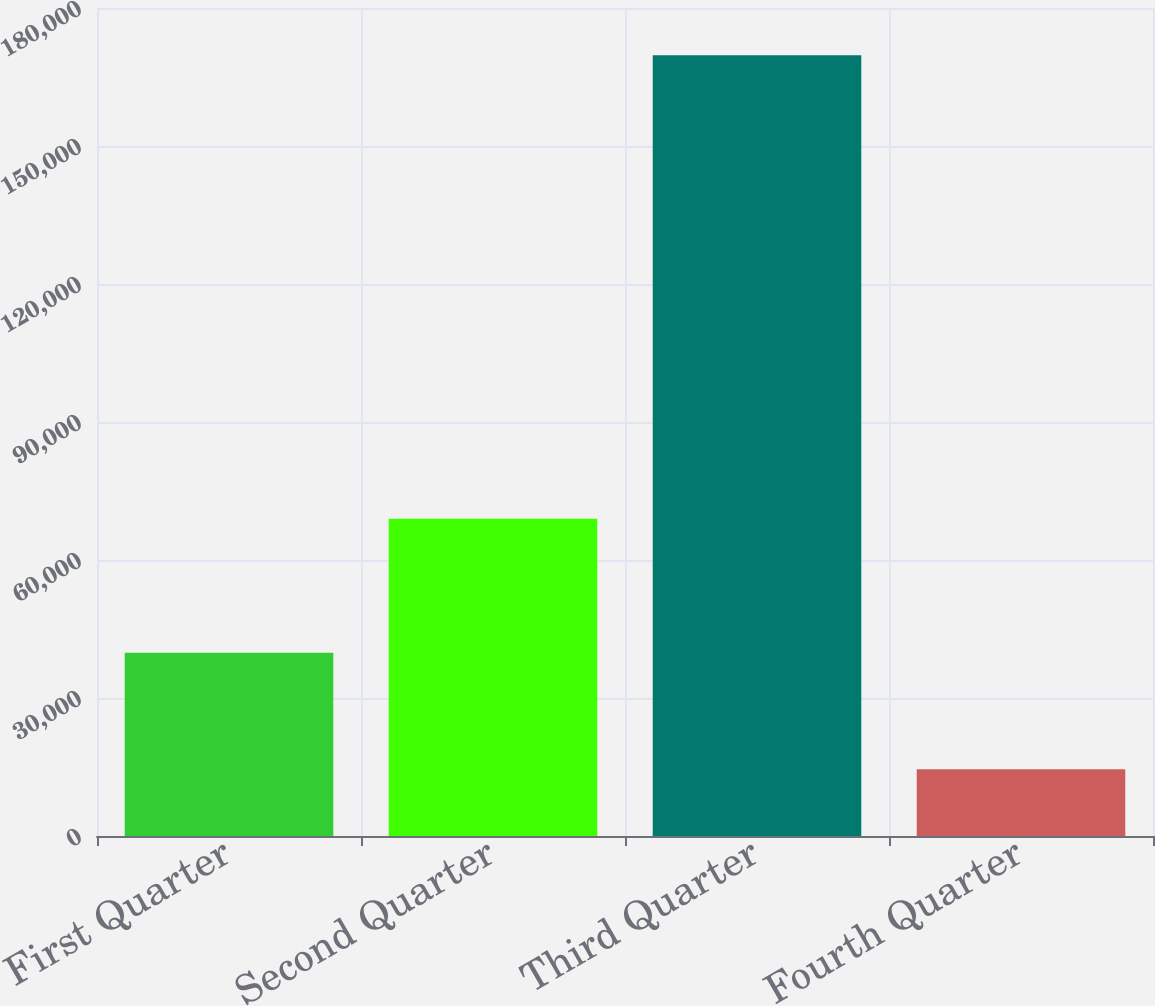Convert chart to OTSL. <chart><loc_0><loc_0><loc_500><loc_500><bar_chart><fcel>First Quarter<fcel>Second Quarter<fcel>Third Quarter<fcel>Fourth Quarter<nl><fcel>39847<fcel>68994<fcel>169755<fcel>14507<nl></chart> 